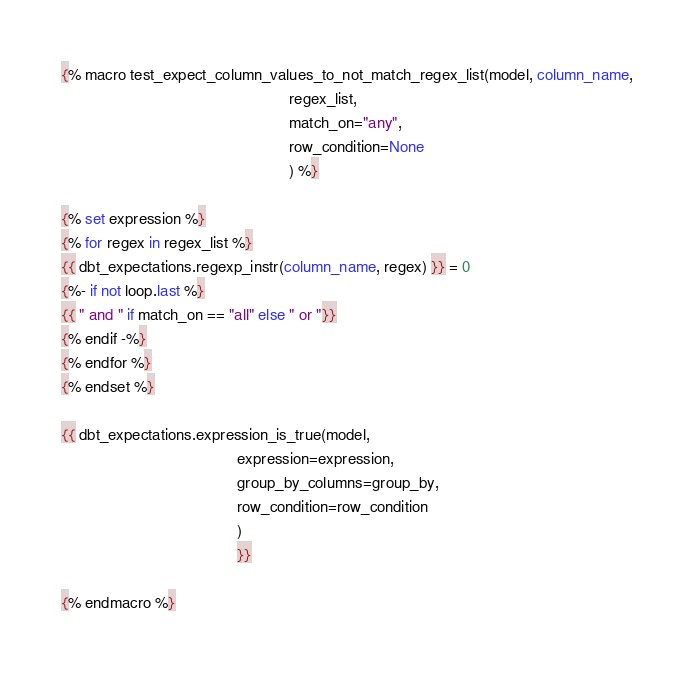<code> <loc_0><loc_0><loc_500><loc_500><_SQL_>{% macro test_expect_column_values_to_not_match_regex_list(model, column_name,
                                                    regex_list,
                                                    match_on="any",
                                                    row_condition=None
                                                    ) %}

{% set expression %}
{% for regex in regex_list %}
{{ dbt_expectations.regexp_instr(column_name, regex) }} = 0
{%- if not loop.last %}
{{ " and " if match_on == "all" else " or "}}
{% endif -%}
{% endfor %}
{% endset %}

{{ dbt_expectations.expression_is_true(model,
                                        expression=expression,
                                        group_by_columns=group_by,
                                        row_condition=row_condition
                                        )
                                        }}

{% endmacro %}
</code> 